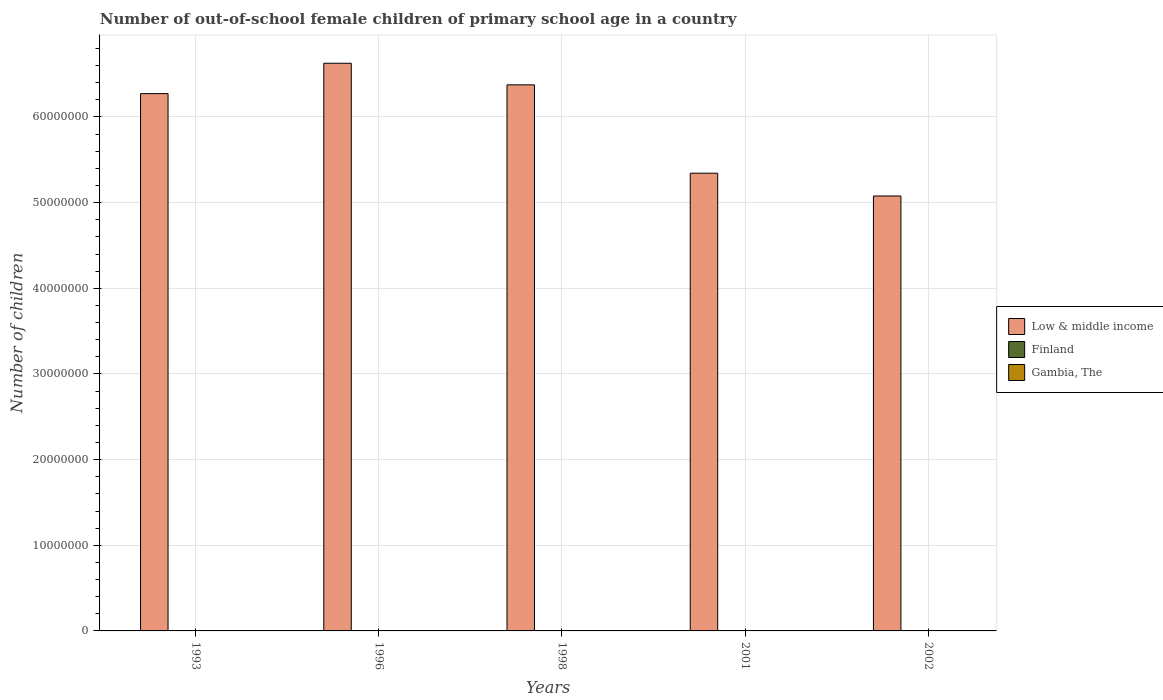Are the number of bars per tick equal to the number of legend labels?
Provide a short and direct response. Yes. How many bars are there on the 4th tick from the left?
Offer a terse response. 3. How many bars are there on the 1st tick from the right?
Your answer should be very brief. 3. In how many cases, is the number of bars for a given year not equal to the number of legend labels?
Provide a succinct answer. 0. What is the number of out-of-school female children in Low & middle income in 2002?
Provide a succinct answer. 5.08e+07. Across all years, what is the maximum number of out-of-school female children in Low & middle income?
Your response must be concise. 6.63e+07. Across all years, what is the minimum number of out-of-school female children in Gambia, The?
Offer a very short reply. 2.83e+04. In which year was the number of out-of-school female children in Low & middle income maximum?
Keep it short and to the point. 1996. What is the total number of out-of-school female children in Finland in the graph?
Provide a succinct answer. 6685. What is the difference between the number of out-of-school female children in Gambia, The in 1996 and that in 1998?
Provide a short and direct response. 2987. What is the difference between the number of out-of-school female children in Gambia, The in 1993 and the number of out-of-school female children in Low & middle income in 2001?
Make the answer very short. -5.34e+07. What is the average number of out-of-school female children in Low & middle income per year?
Offer a terse response. 5.94e+07. In the year 1993, what is the difference between the number of out-of-school female children in Low & middle income and number of out-of-school female children in Gambia, The?
Your answer should be very brief. 6.27e+07. What is the ratio of the number of out-of-school female children in Gambia, The in 1998 to that in 2002?
Give a very brief answer. 1.23. What is the difference between the highest and the second highest number of out-of-school female children in Finland?
Offer a terse response. 45. What is the difference between the highest and the lowest number of out-of-school female children in Gambia, The?
Offer a very short reply. 1.87e+04. Is the sum of the number of out-of-school female children in Gambia, The in 1998 and 2002 greater than the maximum number of out-of-school female children in Finland across all years?
Keep it short and to the point. Yes. What does the 3rd bar from the left in 1996 represents?
Your answer should be very brief. Gambia, The. How many bars are there?
Your response must be concise. 15. How many years are there in the graph?
Provide a short and direct response. 5. How many legend labels are there?
Make the answer very short. 3. How are the legend labels stacked?
Provide a succinct answer. Vertical. What is the title of the graph?
Offer a very short reply. Number of out-of-school female children of primary school age in a country. Does "Belgium" appear as one of the legend labels in the graph?
Ensure brevity in your answer.  No. What is the label or title of the Y-axis?
Your answer should be compact. Number of children. What is the Number of children in Low & middle income in 1993?
Your response must be concise. 6.27e+07. What is the Number of children in Finland in 1993?
Make the answer very short. 2222. What is the Number of children in Gambia, The in 1993?
Your answer should be very brief. 4.70e+04. What is the Number of children in Low & middle income in 1996?
Provide a short and direct response. 6.63e+07. What is the Number of children of Finland in 1996?
Keep it short and to the point. 2267. What is the Number of children in Gambia, The in 1996?
Provide a short and direct response. 4.14e+04. What is the Number of children in Low & middle income in 1998?
Offer a very short reply. 6.38e+07. What is the Number of children in Finland in 1998?
Give a very brief answer. 1004. What is the Number of children of Gambia, The in 1998?
Your response must be concise. 3.85e+04. What is the Number of children in Low & middle income in 2001?
Offer a terse response. 5.34e+07. What is the Number of children in Finland in 2001?
Your answer should be compact. 334. What is the Number of children in Gambia, The in 2001?
Your answer should be very brief. 2.83e+04. What is the Number of children in Low & middle income in 2002?
Keep it short and to the point. 5.08e+07. What is the Number of children of Finland in 2002?
Provide a short and direct response. 858. What is the Number of children in Gambia, The in 2002?
Make the answer very short. 3.12e+04. Across all years, what is the maximum Number of children in Low & middle income?
Provide a short and direct response. 6.63e+07. Across all years, what is the maximum Number of children of Finland?
Your answer should be compact. 2267. Across all years, what is the maximum Number of children of Gambia, The?
Keep it short and to the point. 4.70e+04. Across all years, what is the minimum Number of children in Low & middle income?
Your response must be concise. 5.08e+07. Across all years, what is the minimum Number of children in Finland?
Your answer should be very brief. 334. Across all years, what is the minimum Number of children of Gambia, The?
Offer a very short reply. 2.83e+04. What is the total Number of children in Low & middle income in the graph?
Your answer should be compact. 2.97e+08. What is the total Number of children of Finland in the graph?
Your response must be concise. 6685. What is the total Number of children in Gambia, The in the graph?
Offer a very short reply. 1.87e+05. What is the difference between the Number of children of Low & middle income in 1993 and that in 1996?
Offer a terse response. -3.54e+06. What is the difference between the Number of children in Finland in 1993 and that in 1996?
Offer a terse response. -45. What is the difference between the Number of children of Gambia, The in 1993 and that in 1996?
Provide a succinct answer. 5592. What is the difference between the Number of children of Low & middle income in 1993 and that in 1998?
Keep it short and to the point. -1.02e+06. What is the difference between the Number of children in Finland in 1993 and that in 1998?
Keep it short and to the point. 1218. What is the difference between the Number of children of Gambia, The in 1993 and that in 1998?
Give a very brief answer. 8579. What is the difference between the Number of children in Low & middle income in 1993 and that in 2001?
Your response must be concise. 9.29e+06. What is the difference between the Number of children in Finland in 1993 and that in 2001?
Provide a short and direct response. 1888. What is the difference between the Number of children of Gambia, The in 1993 and that in 2001?
Make the answer very short. 1.87e+04. What is the difference between the Number of children in Low & middle income in 1993 and that in 2002?
Provide a short and direct response. 1.20e+07. What is the difference between the Number of children in Finland in 1993 and that in 2002?
Keep it short and to the point. 1364. What is the difference between the Number of children of Gambia, The in 1993 and that in 2002?
Provide a succinct answer. 1.58e+04. What is the difference between the Number of children of Low & middle income in 1996 and that in 1998?
Offer a terse response. 2.52e+06. What is the difference between the Number of children of Finland in 1996 and that in 1998?
Your response must be concise. 1263. What is the difference between the Number of children of Gambia, The in 1996 and that in 1998?
Offer a very short reply. 2987. What is the difference between the Number of children of Low & middle income in 1996 and that in 2001?
Give a very brief answer. 1.28e+07. What is the difference between the Number of children of Finland in 1996 and that in 2001?
Provide a short and direct response. 1933. What is the difference between the Number of children of Gambia, The in 1996 and that in 2001?
Give a very brief answer. 1.31e+04. What is the difference between the Number of children of Low & middle income in 1996 and that in 2002?
Make the answer very short. 1.55e+07. What is the difference between the Number of children of Finland in 1996 and that in 2002?
Your answer should be compact. 1409. What is the difference between the Number of children in Gambia, The in 1996 and that in 2002?
Make the answer very short. 1.02e+04. What is the difference between the Number of children of Low & middle income in 1998 and that in 2001?
Ensure brevity in your answer.  1.03e+07. What is the difference between the Number of children in Finland in 1998 and that in 2001?
Your answer should be compact. 670. What is the difference between the Number of children of Gambia, The in 1998 and that in 2001?
Offer a terse response. 1.01e+04. What is the difference between the Number of children in Low & middle income in 1998 and that in 2002?
Your answer should be very brief. 1.30e+07. What is the difference between the Number of children of Finland in 1998 and that in 2002?
Keep it short and to the point. 146. What is the difference between the Number of children of Gambia, The in 1998 and that in 2002?
Your answer should be very brief. 7204. What is the difference between the Number of children in Low & middle income in 2001 and that in 2002?
Make the answer very short. 2.66e+06. What is the difference between the Number of children in Finland in 2001 and that in 2002?
Your answer should be compact. -524. What is the difference between the Number of children of Gambia, The in 2001 and that in 2002?
Your answer should be very brief. -2913. What is the difference between the Number of children in Low & middle income in 1993 and the Number of children in Finland in 1996?
Make the answer very short. 6.27e+07. What is the difference between the Number of children in Low & middle income in 1993 and the Number of children in Gambia, The in 1996?
Give a very brief answer. 6.27e+07. What is the difference between the Number of children in Finland in 1993 and the Number of children in Gambia, The in 1996?
Your answer should be compact. -3.92e+04. What is the difference between the Number of children of Low & middle income in 1993 and the Number of children of Finland in 1998?
Ensure brevity in your answer.  6.27e+07. What is the difference between the Number of children of Low & middle income in 1993 and the Number of children of Gambia, The in 1998?
Your answer should be compact. 6.27e+07. What is the difference between the Number of children in Finland in 1993 and the Number of children in Gambia, The in 1998?
Offer a very short reply. -3.62e+04. What is the difference between the Number of children in Low & middle income in 1993 and the Number of children in Finland in 2001?
Make the answer very short. 6.27e+07. What is the difference between the Number of children in Low & middle income in 1993 and the Number of children in Gambia, The in 2001?
Give a very brief answer. 6.27e+07. What is the difference between the Number of children in Finland in 1993 and the Number of children in Gambia, The in 2001?
Keep it short and to the point. -2.61e+04. What is the difference between the Number of children of Low & middle income in 1993 and the Number of children of Finland in 2002?
Your answer should be compact. 6.27e+07. What is the difference between the Number of children in Low & middle income in 1993 and the Number of children in Gambia, The in 2002?
Keep it short and to the point. 6.27e+07. What is the difference between the Number of children of Finland in 1993 and the Number of children of Gambia, The in 2002?
Your answer should be very brief. -2.90e+04. What is the difference between the Number of children in Low & middle income in 1996 and the Number of children in Finland in 1998?
Give a very brief answer. 6.63e+07. What is the difference between the Number of children in Low & middle income in 1996 and the Number of children in Gambia, The in 1998?
Your response must be concise. 6.62e+07. What is the difference between the Number of children of Finland in 1996 and the Number of children of Gambia, The in 1998?
Provide a short and direct response. -3.62e+04. What is the difference between the Number of children of Low & middle income in 1996 and the Number of children of Finland in 2001?
Offer a very short reply. 6.63e+07. What is the difference between the Number of children of Low & middle income in 1996 and the Number of children of Gambia, The in 2001?
Provide a short and direct response. 6.62e+07. What is the difference between the Number of children in Finland in 1996 and the Number of children in Gambia, The in 2001?
Provide a succinct answer. -2.61e+04. What is the difference between the Number of children in Low & middle income in 1996 and the Number of children in Finland in 2002?
Offer a very short reply. 6.63e+07. What is the difference between the Number of children of Low & middle income in 1996 and the Number of children of Gambia, The in 2002?
Give a very brief answer. 6.62e+07. What is the difference between the Number of children in Finland in 1996 and the Number of children in Gambia, The in 2002?
Your answer should be compact. -2.90e+04. What is the difference between the Number of children in Low & middle income in 1998 and the Number of children in Finland in 2001?
Offer a terse response. 6.38e+07. What is the difference between the Number of children of Low & middle income in 1998 and the Number of children of Gambia, The in 2001?
Your answer should be compact. 6.37e+07. What is the difference between the Number of children of Finland in 1998 and the Number of children of Gambia, The in 2001?
Make the answer very short. -2.73e+04. What is the difference between the Number of children in Low & middle income in 1998 and the Number of children in Finland in 2002?
Ensure brevity in your answer.  6.38e+07. What is the difference between the Number of children in Low & middle income in 1998 and the Number of children in Gambia, The in 2002?
Offer a terse response. 6.37e+07. What is the difference between the Number of children in Finland in 1998 and the Number of children in Gambia, The in 2002?
Offer a very short reply. -3.02e+04. What is the difference between the Number of children of Low & middle income in 2001 and the Number of children of Finland in 2002?
Provide a succinct answer. 5.34e+07. What is the difference between the Number of children in Low & middle income in 2001 and the Number of children in Gambia, The in 2002?
Your response must be concise. 5.34e+07. What is the difference between the Number of children of Finland in 2001 and the Number of children of Gambia, The in 2002?
Your answer should be very brief. -3.09e+04. What is the average Number of children of Low & middle income per year?
Make the answer very short. 5.94e+07. What is the average Number of children of Finland per year?
Your response must be concise. 1337. What is the average Number of children of Gambia, The per year?
Your answer should be compact. 3.73e+04. In the year 1993, what is the difference between the Number of children in Low & middle income and Number of children in Finland?
Provide a succinct answer. 6.27e+07. In the year 1993, what is the difference between the Number of children of Low & middle income and Number of children of Gambia, The?
Keep it short and to the point. 6.27e+07. In the year 1993, what is the difference between the Number of children of Finland and Number of children of Gambia, The?
Provide a succinct answer. -4.48e+04. In the year 1996, what is the difference between the Number of children of Low & middle income and Number of children of Finland?
Your answer should be very brief. 6.63e+07. In the year 1996, what is the difference between the Number of children in Low & middle income and Number of children in Gambia, The?
Give a very brief answer. 6.62e+07. In the year 1996, what is the difference between the Number of children in Finland and Number of children in Gambia, The?
Your answer should be very brief. -3.92e+04. In the year 1998, what is the difference between the Number of children of Low & middle income and Number of children of Finland?
Offer a terse response. 6.38e+07. In the year 1998, what is the difference between the Number of children of Low & middle income and Number of children of Gambia, The?
Provide a succinct answer. 6.37e+07. In the year 1998, what is the difference between the Number of children in Finland and Number of children in Gambia, The?
Ensure brevity in your answer.  -3.74e+04. In the year 2001, what is the difference between the Number of children in Low & middle income and Number of children in Finland?
Your answer should be very brief. 5.34e+07. In the year 2001, what is the difference between the Number of children of Low & middle income and Number of children of Gambia, The?
Your answer should be very brief. 5.34e+07. In the year 2001, what is the difference between the Number of children of Finland and Number of children of Gambia, The?
Ensure brevity in your answer.  -2.80e+04. In the year 2002, what is the difference between the Number of children in Low & middle income and Number of children in Finland?
Your answer should be very brief. 5.08e+07. In the year 2002, what is the difference between the Number of children in Low & middle income and Number of children in Gambia, The?
Your answer should be very brief. 5.07e+07. In the year 2002, what is the difference between the Number of children of Finland and Number of children of Gambia, The?
Offer a terse response. -3.04e+04. What is the ratio of the Number of children of Low & middle income in 1993 to that in 1996?
Ensure brevity in your answer.  0.95. What is the ratio of the Number of children of Finland in 1993 to that in 1996?
Offer a terse response. 0.98. What is the ratio of the Number of children of Gambia, The in 1993 to that in 1996?
Keep it short and to the point. 1.13. What is the ratio of the Number of children in Low & middle income in 1993 to that in 1998?
Your response must be concise. 0.98. What is the ratio of the Number of children of Finland in 1993 to that in 1998?
Keep it short and to the point. 2.21. What is the ratio of the Number of children in Gambia, The in 1993 to that in 1998?
Your answer should be very brief. 1.22. What is the ratio of the Number of children in Low & middle income in 1993 to that in 2001?
Ensure brevity in your answer.  1.17. What is the ratio of the Number of children of Finland in 1993 to that in 2001?
Keep it short and to the point. 6.65. What is the ratio of the Number of children of Gambia, The in 1993 to that in 2001?
Ensure brevity in your answer.  1.66. What is the ratio of the Number of children of Low & middle income in 1993 to that in 2002?
Offer a terse response. 1.24. What is the ratio of the Number of children in Finland in 1993 to that in 2002?
Keep it short and to the point. 2.59. What is the ratio of the Number of children in Gambia, The in 1993 to that in 2002?
Your answer should be very brief. 1.51. What is the ratio of the Number of children of Low & middle income in 1996 to that in 1998?
Keep it short and to the point. 1.04. What is the ratio of the Number of children in Finland in 1996 to that in 1998?
Provide a short and direct response. 2.26. What is the ratio of the Number of children of Gambia, The in 1996 to that in 1998?
Make the answer very short. 1.08. What is the ratio of the Number of children in Low & middle income in 1996 to that in 2001?
Keep it short and to the point. 1.24. What is the ratio of the Number of children in Finland in 1996 to that in 2001?
Provide a short and direct response. 6.79. What is the ratio of the Number of children in Gambia, The in 1996 to that in 2001?
Offer a very short reply. 1.46. What is the ratio of the Number of children in Low & middle income in 1996 to that in 2002?
Make the answer very short. 1.31. What is the ratio of the Number of children of Finland in 1996 to that in 2002?
Keep it short and to the point. 2.64. What is the ratio of the Number of children of Gambia, The in 1996 to that in 2002?
Provide a succinct answer. 1.33. What is the ratio of the Number of children in Low & middle income in 1998 to that in 2001?
Provide a succinct answer. 1.19. What is the ratio of the Number of children of Finland in 1998 to that in 2001?
Your response must be concise. 3.01. What is the ratio of the Number of children of Gambia, The in 1998 to that in 2001?
Your response must be concise. 1.36. What is the ratio of the Number of children in Low & middle income in 1998 to that in 2002?
Keep it short and to the point. 1.26. What is the ratio of the Number of children of Finland in 1998 to that in 2002?
Your answer should be very brief. 1.17. What is the ratio of the Number of children of Gambia, The in 1998 to that in 2002?
Provide a short and direct response. 1.23. What is the ratio of the Number of children of Low & middle income in 2001 to that in 2002?
Provide a succinct answer. 1.05. What is the ratio of the Number of children of Finland in 2001 to that in 2002?
Ensure brevity in your answer.  0.39. What is the ratio of the Number of children of Gambia, The in 2001 to that in 2002?
Ensure brevity in your answer.  0.91. What is the difference between the highest and the second highest Number of children of Low & middle income?
Make the answer very short. 2.52e+06. What is the difference between the highest and the second highest Number of children of Finland?
Offer a very short reply. 45. What is the difference between the highest and the second highest Number of children of Gambia, The?
Ensure brevity in your answer.  5592. What is the difference between the highest and the lowest Number of children of Low & middle income?
Make the answer very short. 1.55e+07. What is the difference between the highest and the lowest Number of children of Finland?
Offer a terse response. 1933. What is the difference between the highest and the lowest Number of children in Gambia, The?
Your response must be concise. 1.87e+04. 